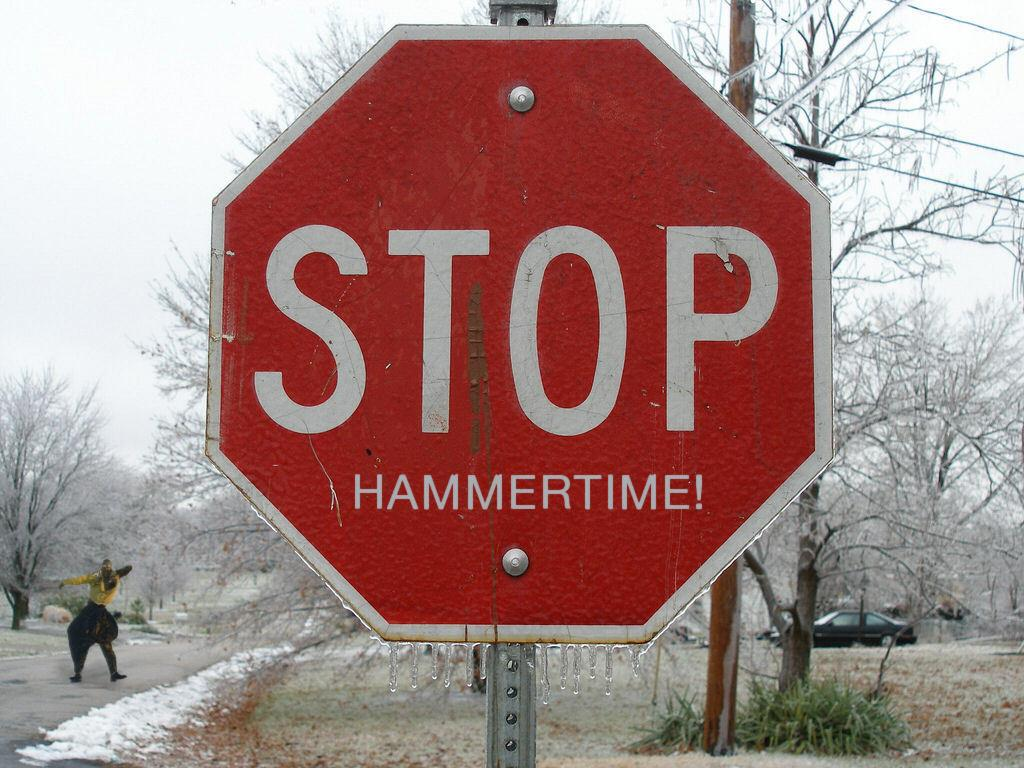<image>
Share a concise interpretation of the image provided. a stop sign that is outside and a lot of snow around it 